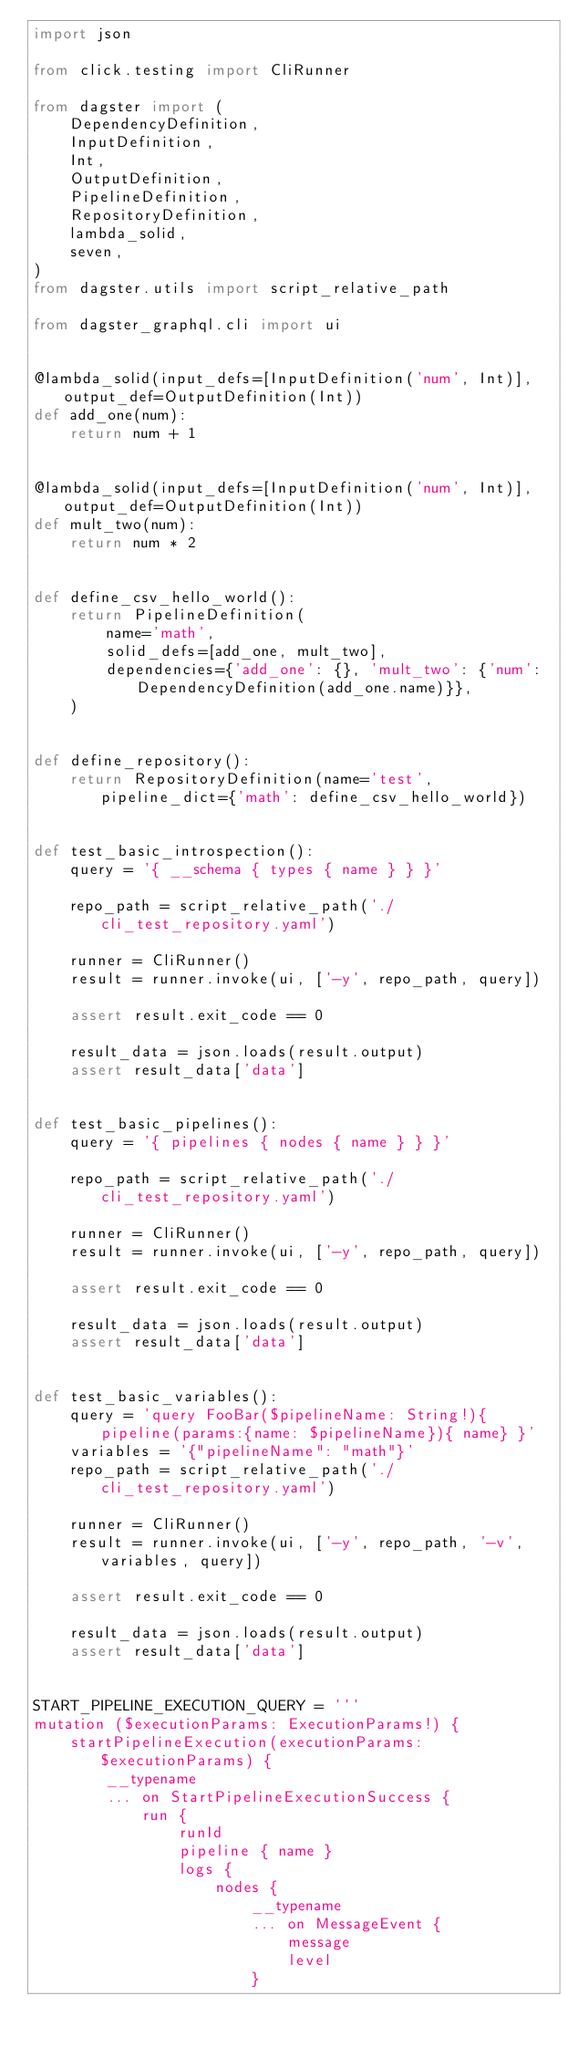<code> <loc_0><loc_0><loc_500><loc_500><_Python_>import json

from click.testing import CliRunner

from dagster import (
    DependencyDefinition,
    InputDefinition,
    Int,
    OutputDefinition,
    PipelineDefinition,
    RepositoryDefinition,
    lambda_solid,
    seven,
)
from dagster.utils import script_relative_path

from dagster_graphql.cli import ui


@lambda_solid(input_defs=[InputDefinition('num', Int)], output_def=OutputDefinition(Int))
def add_one(num):
    return num + 1


@lambda_solid(input_defs=[InputDefinition('num', Int)], output_def=OutputDefinition(Int))
def mult_two(num):
    return num * 2


def define_csv_hello_world():
    return PipelineDefinition(
        name='math',
        solid_defs=[add_one, mult_two],
        dependencies={'add_one': {}, 'mult_two': {'num': DependencyDefinition(add_one.name)}},
    )


def define_repository():
    return RepositoryDefinition(name='test', pipeline_dict={'math': define_csv_hello_world})


def test_basic_introspection():
    query = '{ __schema { types { name } } }'

    repo_path = script_relative_path('./cli_test_repository.yaml')

    runner = CliRunner()
    result = runner.invoke(ui, ['-y', repo_path, query])

    assert result.exit_code == 0

    result_data = json.loads(result.output)
    assert result_data['data']


def test_basic_pipelines():
    query = '{ pipelines { nodes { name } } }'

    repo_path = script_relative_path('./cli_test_repository.yaml')

    runner = CliRunner()
    result = runner.invoke(ui, ['-y', repo_path, query])

    assert result.exit_code == 0

    result_data = json.loads(result.output)
    assert result_data['data']


def test_basic_variables():
    query = 'query FooBar($pipelineName: String!){ pipeline(params:{name: $pipelineName}){ name} }'
    variables = '{"pipelineName": "math"}'
    repo_path = script_relative_path('./cli_test_repository.yaml')

    runner = CliRunner()
    result = runner.invoke(ui, ['-y', repo_path, '-v', variables, query])

    assert result.exit_code == 0

    result_data = json.loads(result.output)
    assert result_data['data']


START_PIPELINE_EXECUTION_QUERY = '''
mutation ($executionParams: ExecutionParams!) {
    startPipelineExecution(executionParams: $executionParams) {
        __typename
        ... on StartPipelineExecutionSuccess {
            run {
                runId
                pipeline { name }
                logs {
                    nodes {
                        __typename
                        ... on MessageEvent {
                            message
                            level
                        }</code> 